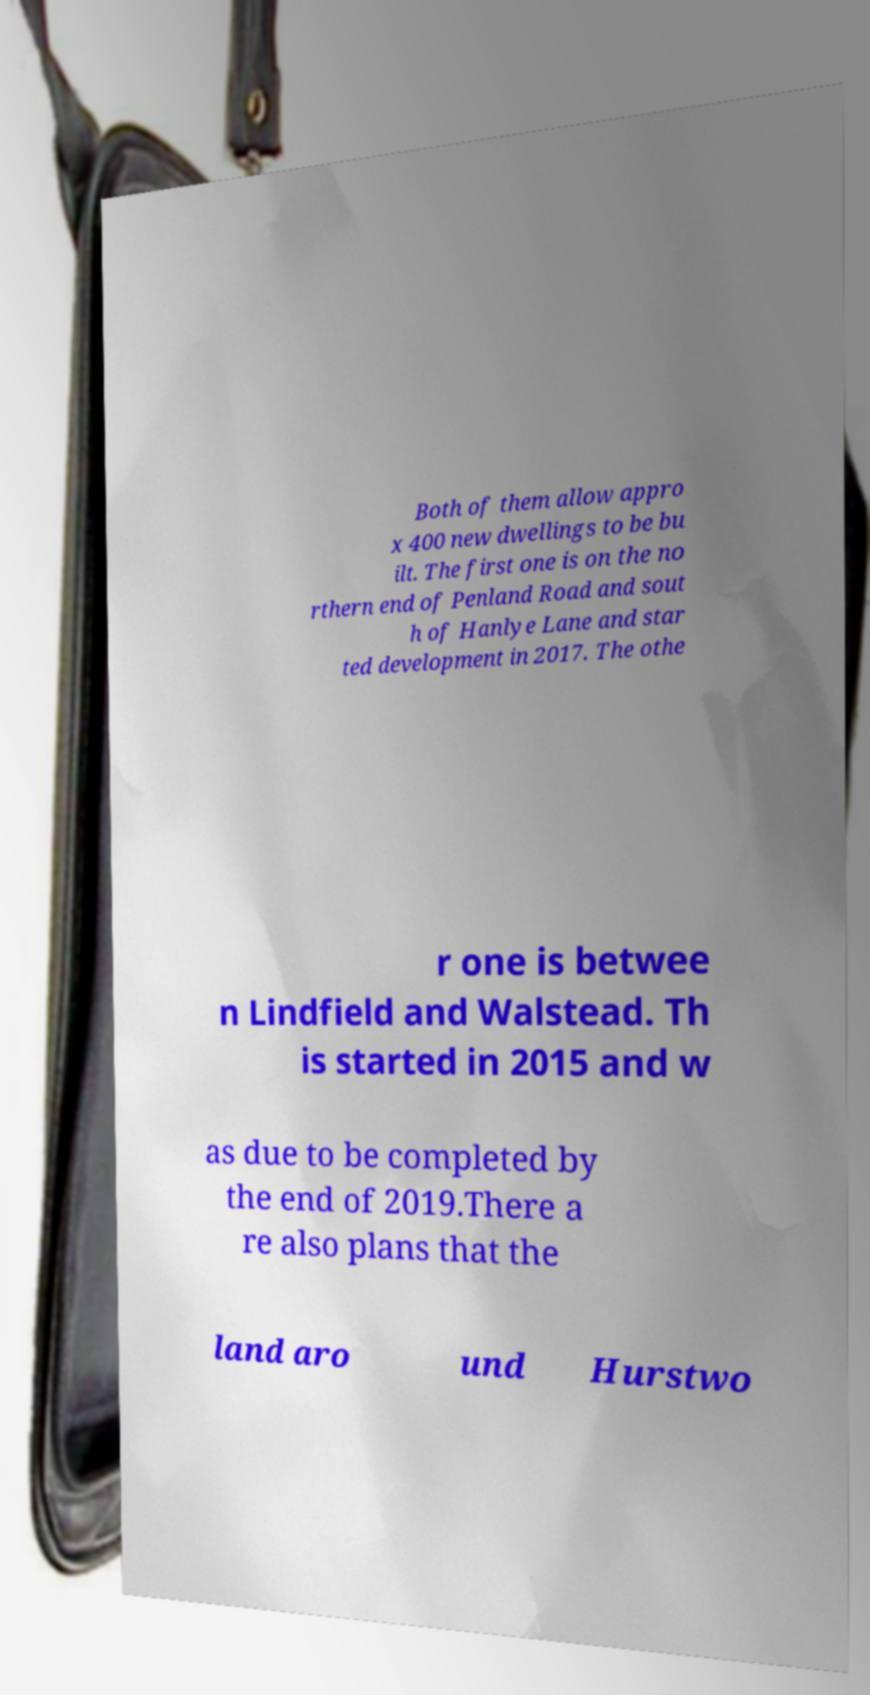I need the written content from this picture converted into text. Can you do that? Both of them allow appro x 400 new dwellings to be bu ilt. The first one is on the no rthern end of Penland Road and sout h of Hanlye Lane and star ted development in 2017. The othe r one is betwee n Lindfield and Walstead. Th is started in 2015 and w as due to be completed by the end of 2019.There a re also plans that the land aro und Hurstwo 